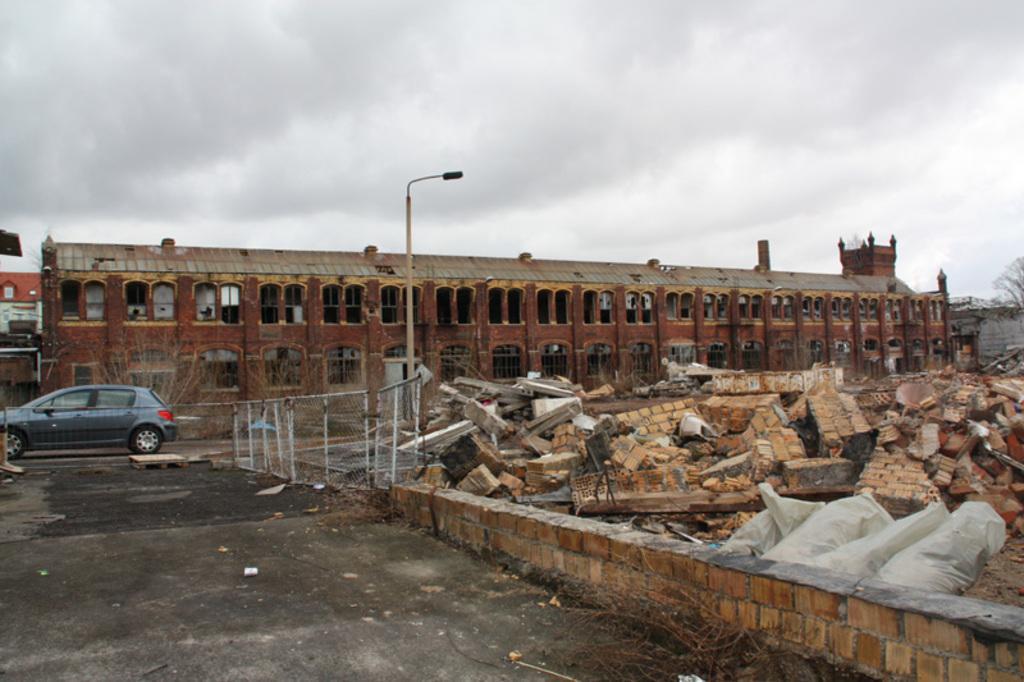In one or two sentences, can you explain what this image depicts? In the picture we can see a path beside it we can see a fencing and a pole with a light and near it we can see some demolished house walls and bricks and behind it we can see a building which is very old and behind it we can see a sky with clouds and near to the building we can see a car parked. 